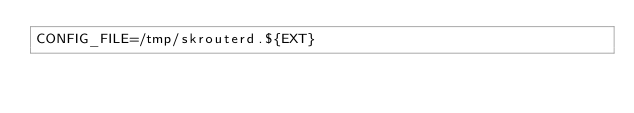Convert code to text. <code><loc_0><loc_0><loc_500><loc_500><_Bash_>CONFIG_FILE=/tmp/skrouterd.${EXT}
</code> 